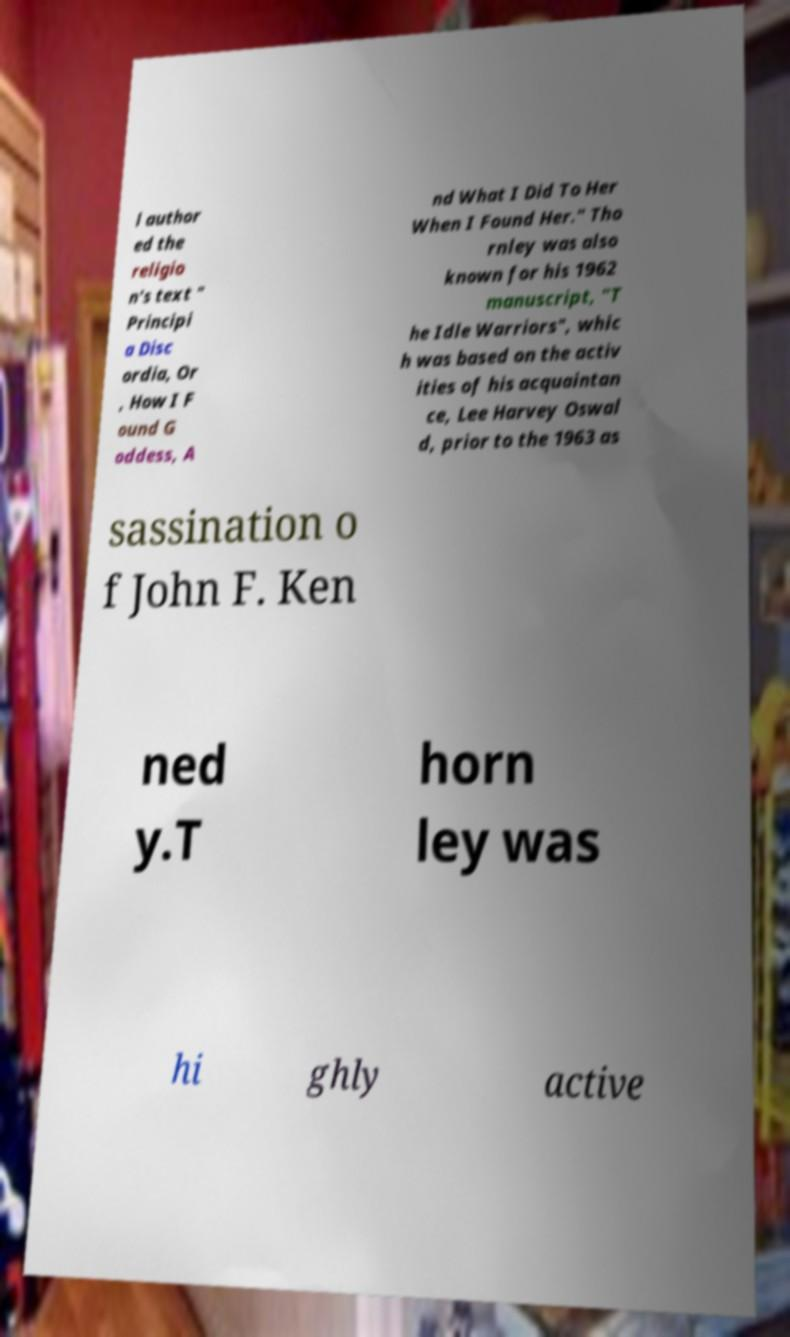Please identify and transcribe the text found in this image. l author ed the religio n's text " Principi a Disc ordia, Or , How I F ound G oddess, A nd What I Did To Her When I Found Her." Tho rnley was also known for his 1962 manuscript, "T he Idle Warriors", whic h was based on the activ ities of his acquaintan ce, Lee Harvey Oswal d, prior to the 1963 as sassination o f John F. Ken ned y.T horn ley was hi ghly active 